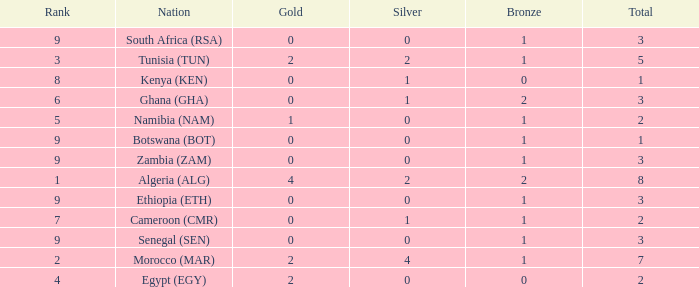What is the lowest Bronze with a Nation of egypt (egy) and with a Gold that is smaller than 2? None. Give me the full table as a dictionary. {'header': ['Rank', 'Nation', 'Gold', 'Silver', 'Bronze', 'Total'], 'rows': [['9', 'South Africa (RSA)', '0', '0', '1', '3'], ['3', 'Tunisia (TUN)', '2', '2', '1', '5'], ['8', 'Kenya (KEN)', '0', '1', '0', '1'], ['6', 'Ghana (GHA)', '0', '1', '2', '3'], ['5', 'Namibia (NAM)', '1', '0', '1', '2'], ['9', 'Botswana (BOT)', '0', '0', '1', '1'], ['9', 'Zambia (ZAM)', '0', '0', '1', '3'], ['1', 'Algeria (ALG)', '4', '2', '2', '8'], ['9', 'Ethiopia (ETH)', '0', '0', '1', '3'], ['7', 'Cameroon (CMR)', '0', '1', '1', '2'], ['9', 'Senegal (SEN)', '0', '0', '1', '3'], ['2', 'Morocco (MAR)', '2', '4', '1', '7'], ['4', 'Egypt (EGY)', '2', '0', '0', '2']]} 